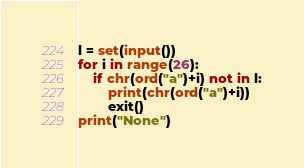Convert code to text. <code><loc_0><loc_0><loc_500><loc_500><_Python_>l = set(input())
for i in range(26):
    if chr(ord("a")+i) not in l:
        print(chr(ord("a")+i))
        exit()
print("None")</code> 